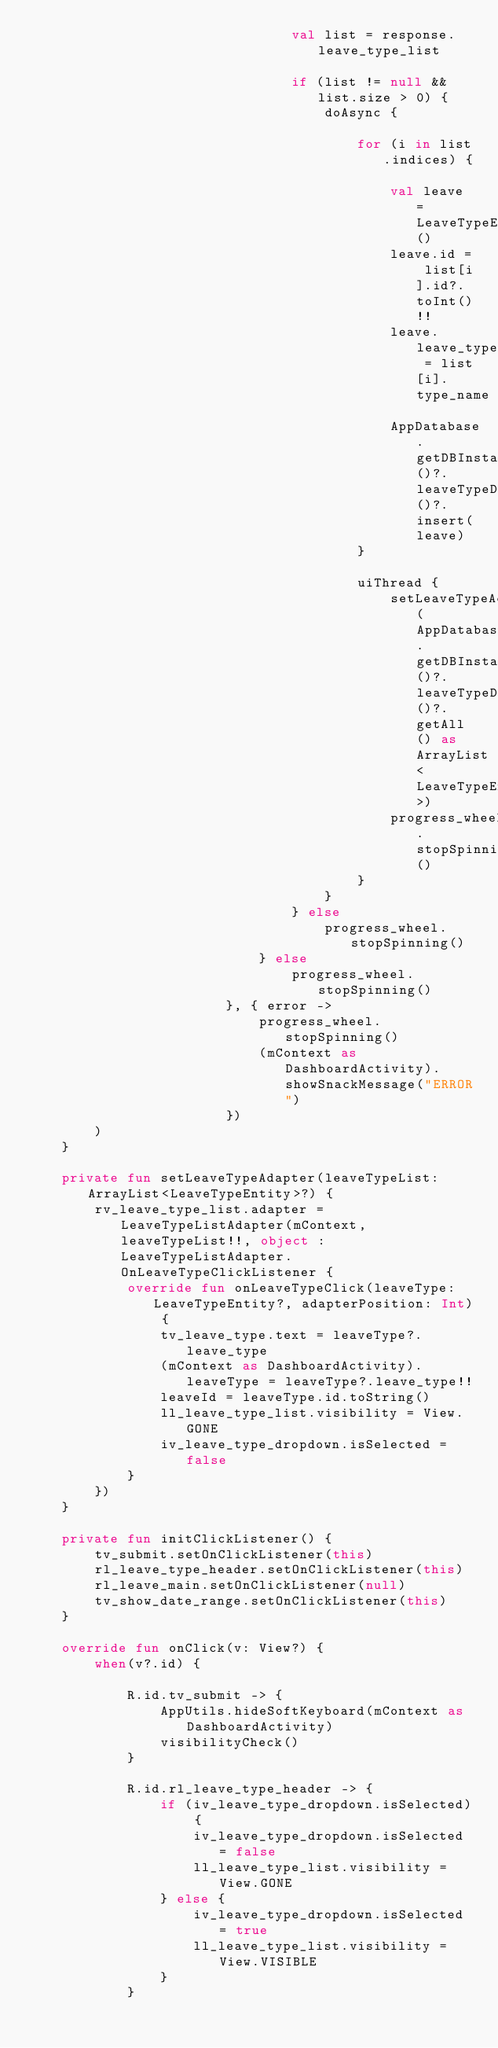Convert code to text. <code><loc_0><loc_0><loc_500><loc_500><_Kotlin_>                                val list = response.leave_type_list

                                if (list != null && list.size > 0) {
                                    doAsync {

                                        for (i in list.indices) {

                                            val leave = LeaveTypeEntity()
                                            leave.id = list[i].id?.toInt()!!
                                            leave.leave_type = list[i].type_name
                                            AppDatabase.getDBInstance()?.leaveTypeDao()?.insert(leave)
                                        }

                                        uiThread {
                                            setLeaveTypeAdapter(AppDatabase.getDBInstance()?.leaveTypeDao()?.getAll() as ArrayList<LeaveTypeEntity>)
                                            progress_wheel.stopSpinning()
                                        }
                                    }
                                } else
                                    progress_wheel.stopSpinning()
                            } else
                                progress_wheel.stopSpinning()
                        }, { error ->
                            progress_wheel.stopSpinning()
                            (mContext as DashboardActivity).showSnackMessage("ERROR")
                        })
        )
    }

    private fun setLeaveTypeAdapter(leaveTypeList: ArrayList<LeaveTypeEntity>?) {
        rv_leave_type_list.adapter = LeaveTypeListAdapter(mContext, leaveTypeList!!, object : LeaveTypeListAdapter.OnLeaveTypeClickListener {
            override fun onLeaveTypeClick(leaveType: LeaveTypeEntity?, adapterPosition: Int) {
                tv_leave_type.text = leaveType?.leave_type
                (mContext as DashboardActivity).leaveType = leaveType?.leave_type!!
                leaveId = leaveType.id.toString()
                ll_leave_type_list.visibility = View.GONE
                iv_leave_type_dropdown.isSelected = false
            }
        })
    }

    private fun initClickListener() {
        tv_submit.setOnClickListener(this)
        rl_leave_type_header.setOnClickListener(this)
        rl_leave_main.setOnClickListener(null)
        tv_show_date_range.setOnClickListener(this)
    }

    override fun onClick(v: View?) {
        when(v?.id) {

            R.id.tv_submit -> {
                AppUtils.hideSoftKeyboard(mContext as DashboardActivity)
                visibilityCheck()
            }

            R.id.rl_leave_type_header -> {
                if (iv_leave_type_dropdown.isSelected) {
                    iv_leave_type_dropdown.isSelected = false
                    ll_leave_type_list.visibility = View.GONE
                } else {
                    iv_leave_type_dropdown.isSelected = true
                    ll_leave_type_list.visibility = View.VISIBLE
                }
            }
</code> 